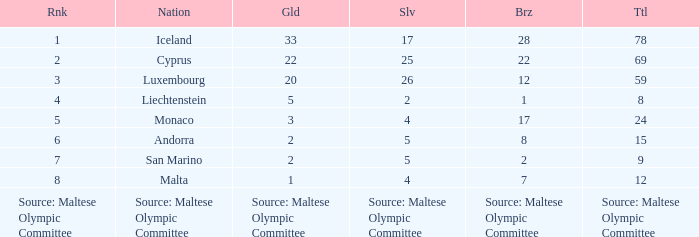Can you give me this table as a dict? {'header': ['Rnk', 'Nation', 'Gld', 'Slv', 'Brz', 'Ttl'], 'rows': [['1', 'Iceland', '33', '17', '28', '78'], ['2', 'Cyprus', '22', '25', '22', '69'], ['3', 'Luxembourg', '20', '26', '12', '59'], ['4', 'Liechtenstein', '5', '2', '1', '8'], ['5', 'Monaco', '3', '4', '17', '24'], ['6', 'Andorra', '2', '5', '8', '15'], ['7', 'San Marino', '2', '5', '2', '9'], ['8', 'Malta', '1', '4', '7', '12'], ['Source: Maltese Olympic Committee', 'Source: Maltese Olympic Committee', 'Source: Maltese Olympic Committee', 'Source: Maltese Olympic Committee', 'Source: Maltese Olympic Committee', 'Source: Maltese Olympic Committee']]} What's the count of bronze medals for the nation with the number 1 ranking? 28.0. 